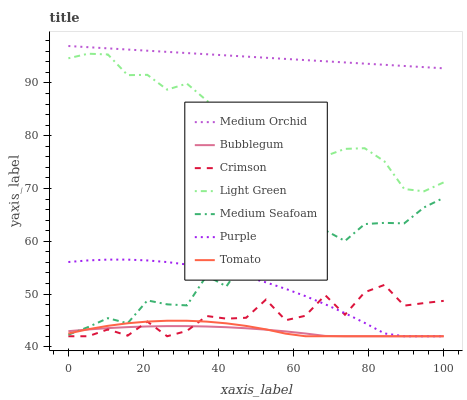Does Bubblegum have the minimum area under the curve?
Answer yes or no. Yes. Does Medium Orchid have the maximum area under the curve?
Answer yes or no. Yes. Does Purple have the minimum area under the curve?
Answer yes or no. No. Does Purple have the maximum area under the curve?
Answer yes or no. No. Is Medium Orchid the smoothest?
Answer yes or no. Yes. Is Medium Seafoam the roughest?
Answer yes or no. Yes. Is Purple the smoothest?
Answer yes or no. No. Is Purple the roughest?
Answer yes or no. No. Does Tomato have the lowest value?
Answer yes or no. Yes. Does Medium Orchid have the lowest value?
Answer yes or no. No. Does Medium Orchid have the highest value?
Answer yes or no. Yes. Does Purple have the highest value?
Answer yes or no. No. Is Medium Seafoam less than Medium Orchid?
Answer yes or no. Yes. Is Medium Orchid greater than Light Green?
Answer yes or no. Yes. Does Tomato intersect Bubblegum?
Answer yes or no. Yes. Is Tomato less than Bubblegum?
Answer yes or no. No. Is Tomato greater than Bubblegum?
Answer yes or no. No. Does Medium Seafoam intersect Medium Orchid?
Answer yes or no. No. 